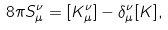Convert formula to latex. <formula><loc_0><loc_0><loc_500><loc_500>8 \pi S _ { \mu } ^ { \nu } = [ K _ { \mu } ^ { \nu } ] - \delta _ { \mu } ^ { \nu } [ K ] ,</formula> 